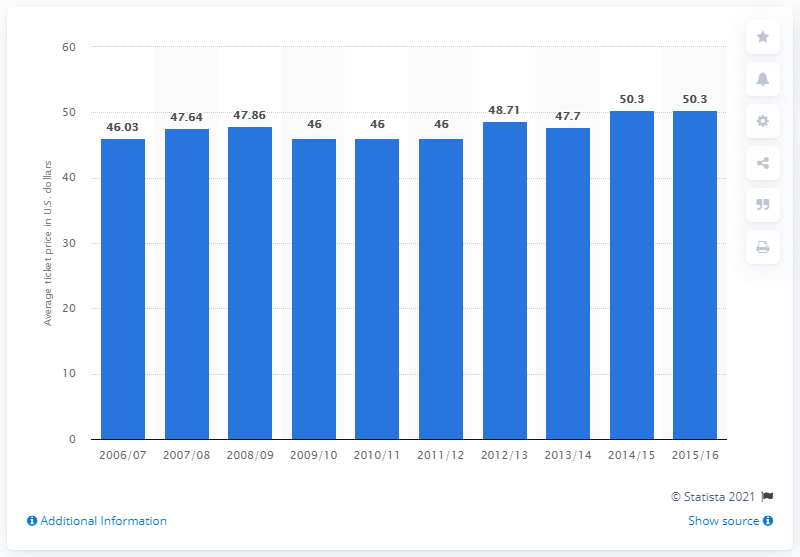Highlight a few significant elements in this photo. The average ticket price for Milwaukee Bucks games in the 2006/07 season was 46.03 dollars. 